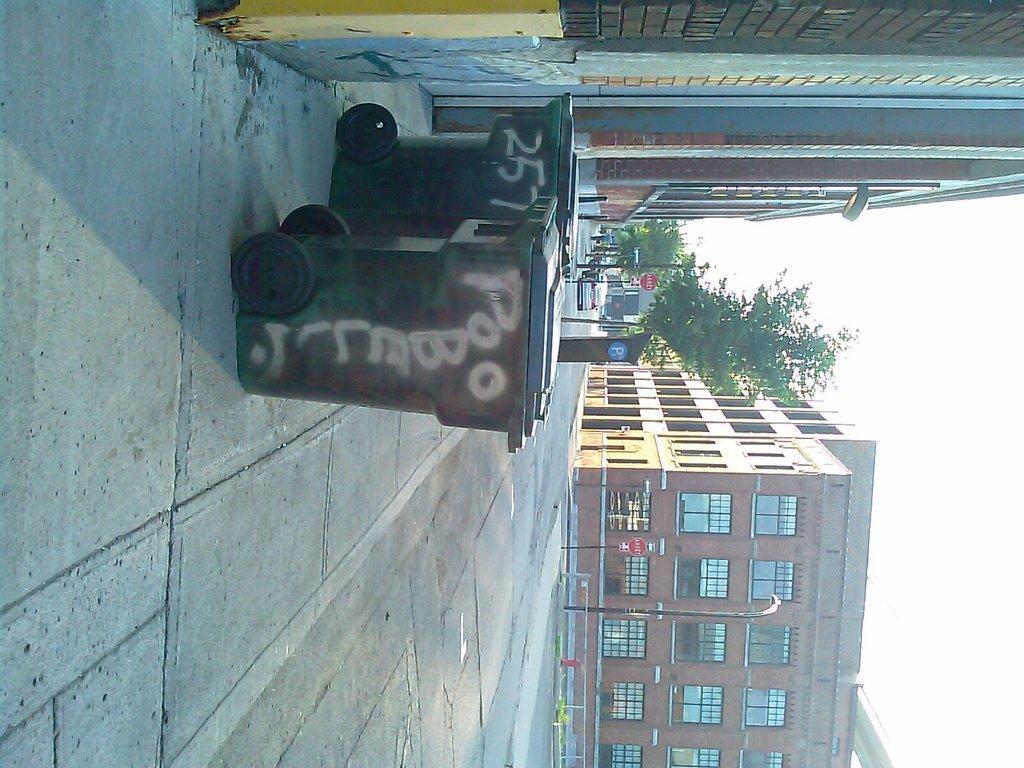How would you summarize this image in a sentence or two? In this picture I can observe trash bins in front of a wall. There is a road. I can observe some poles on either sides of the road. There are buildings, trees and sky. 